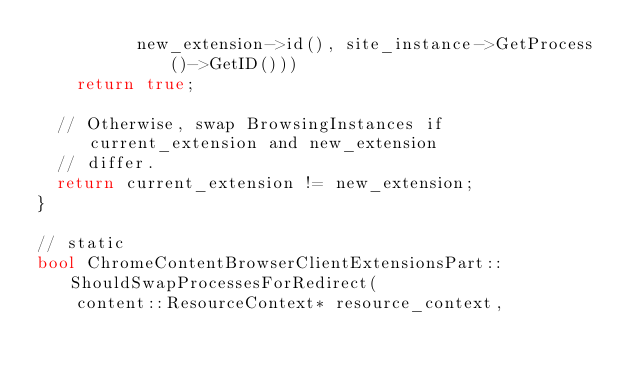Convert code to text. <code><loc_0><loc_0><loc_500><loc_500><_C++_>          new_extension->id(), site_instance->GetProcess()->GetID()))
    return true;

  // Otherwise, swap BrowsingInstances if current_extension and new_extension
  // differ.
  return current_extension != new_extension;
}

// static
bool ChromeContentBrowserClientExtensionsPart::ShouldSwapProcessesForRedirect(
    content::ResourceContext* resource_context,</code> 